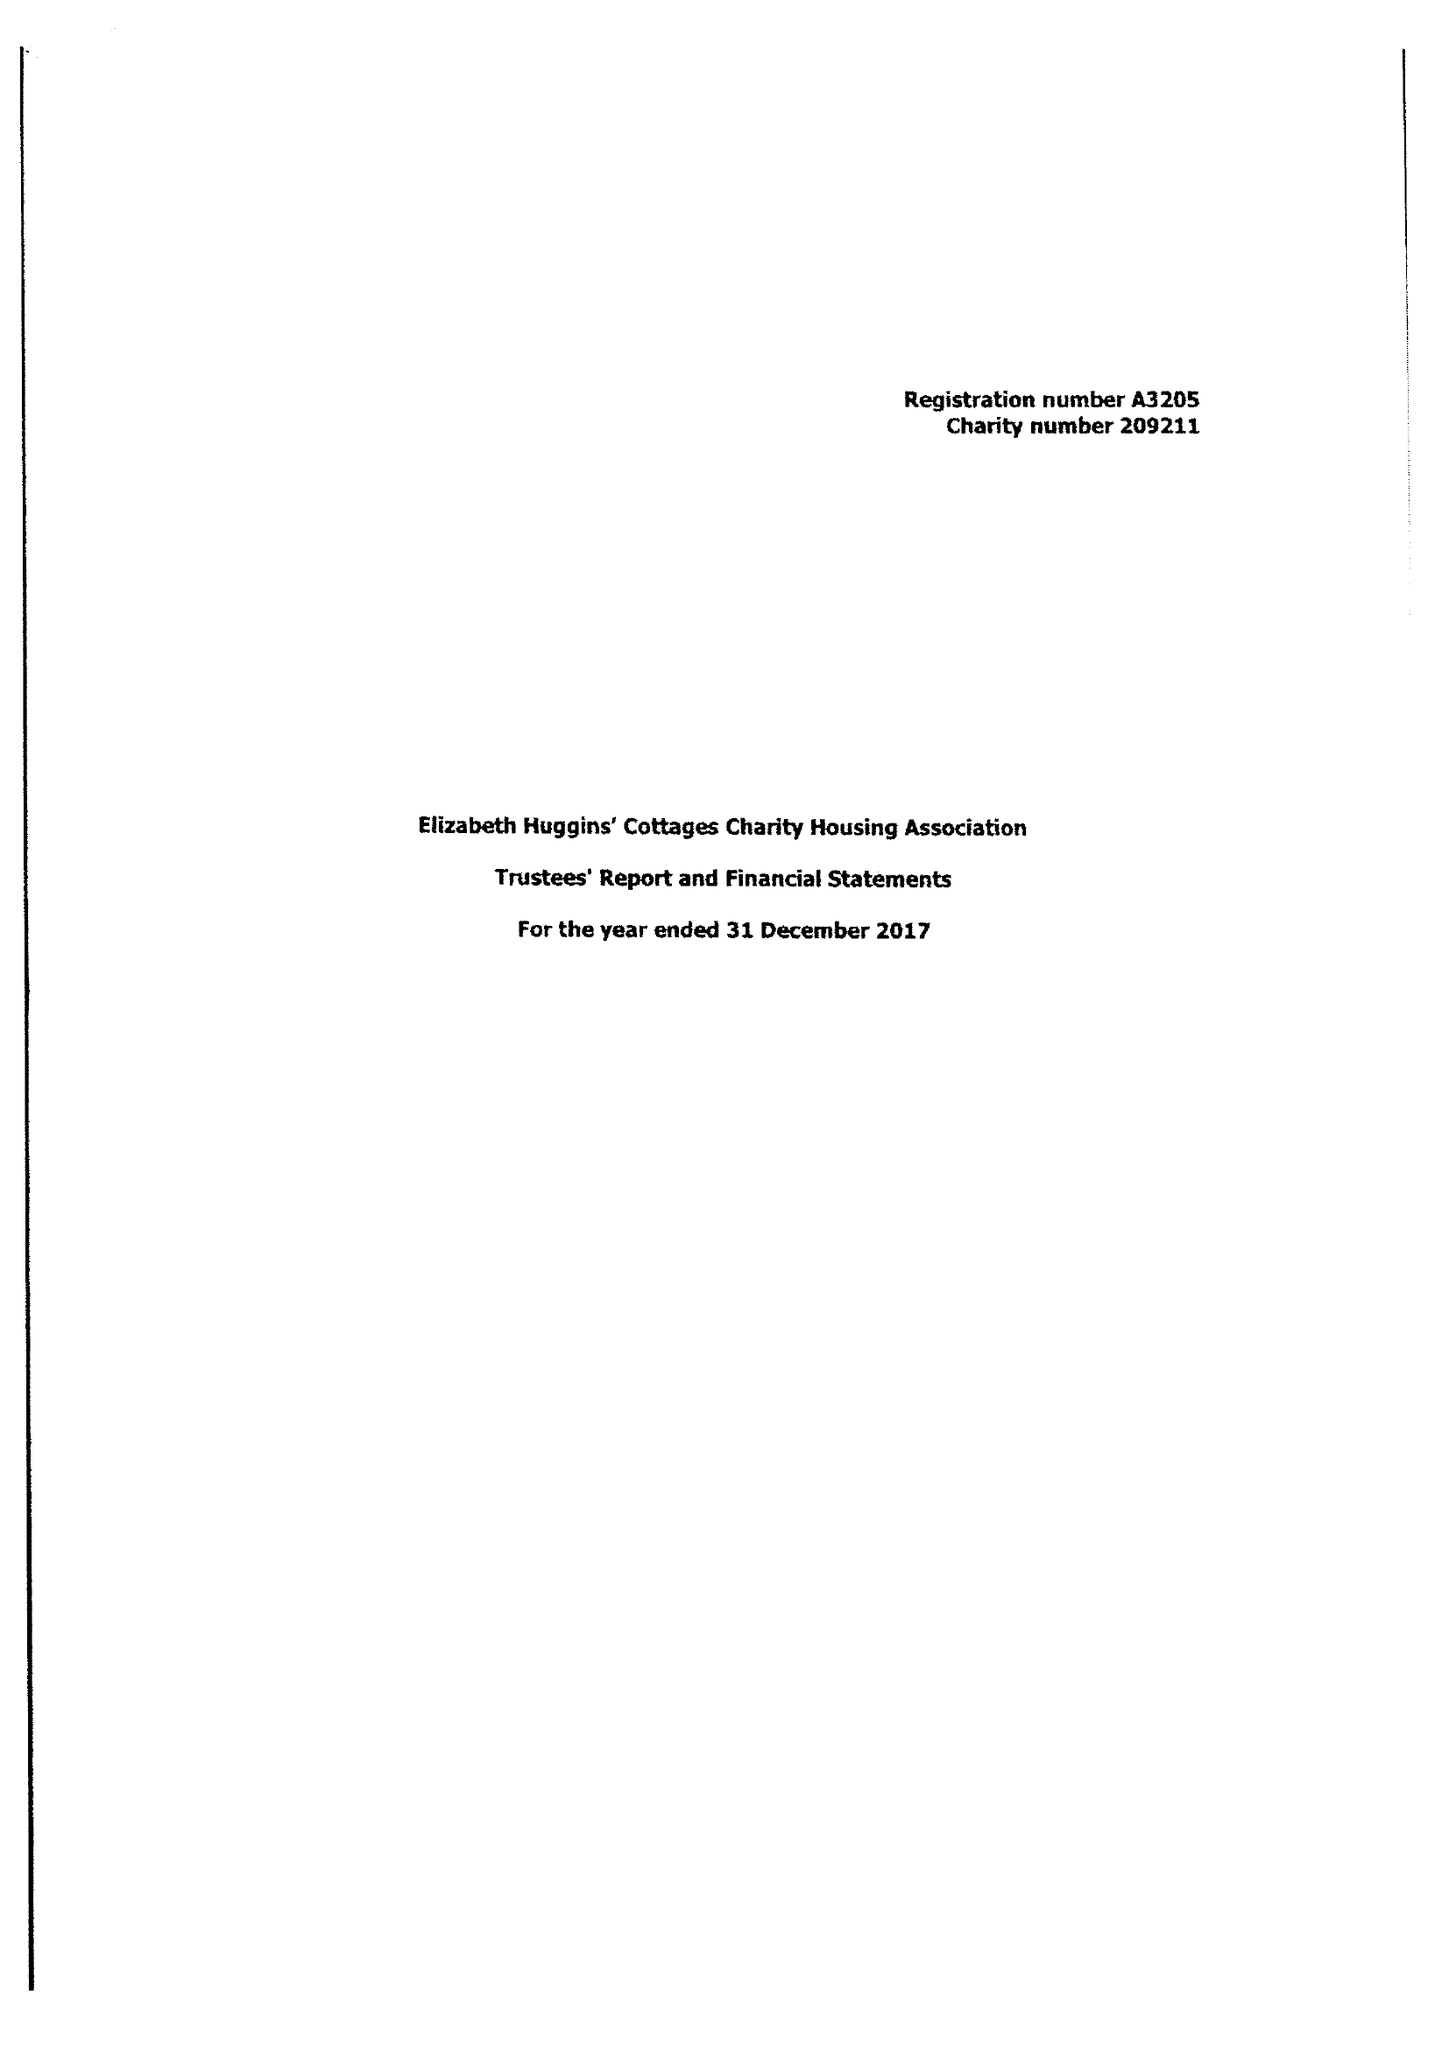What is the value for the income_annually_in_british_pounds?
Answer the question using a single word or phrase. 69632.00 